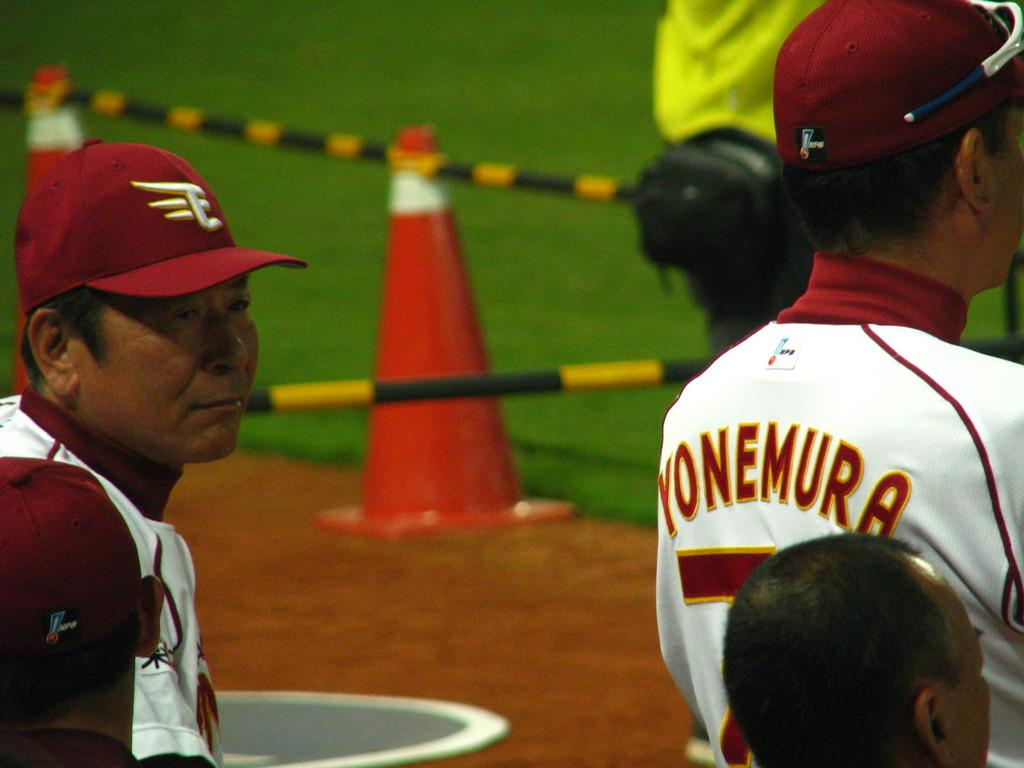<image>
Give a short and clear explanation of the subsequent image. Yonemura is wearing a baseball uniform on a field with an orange cone. 